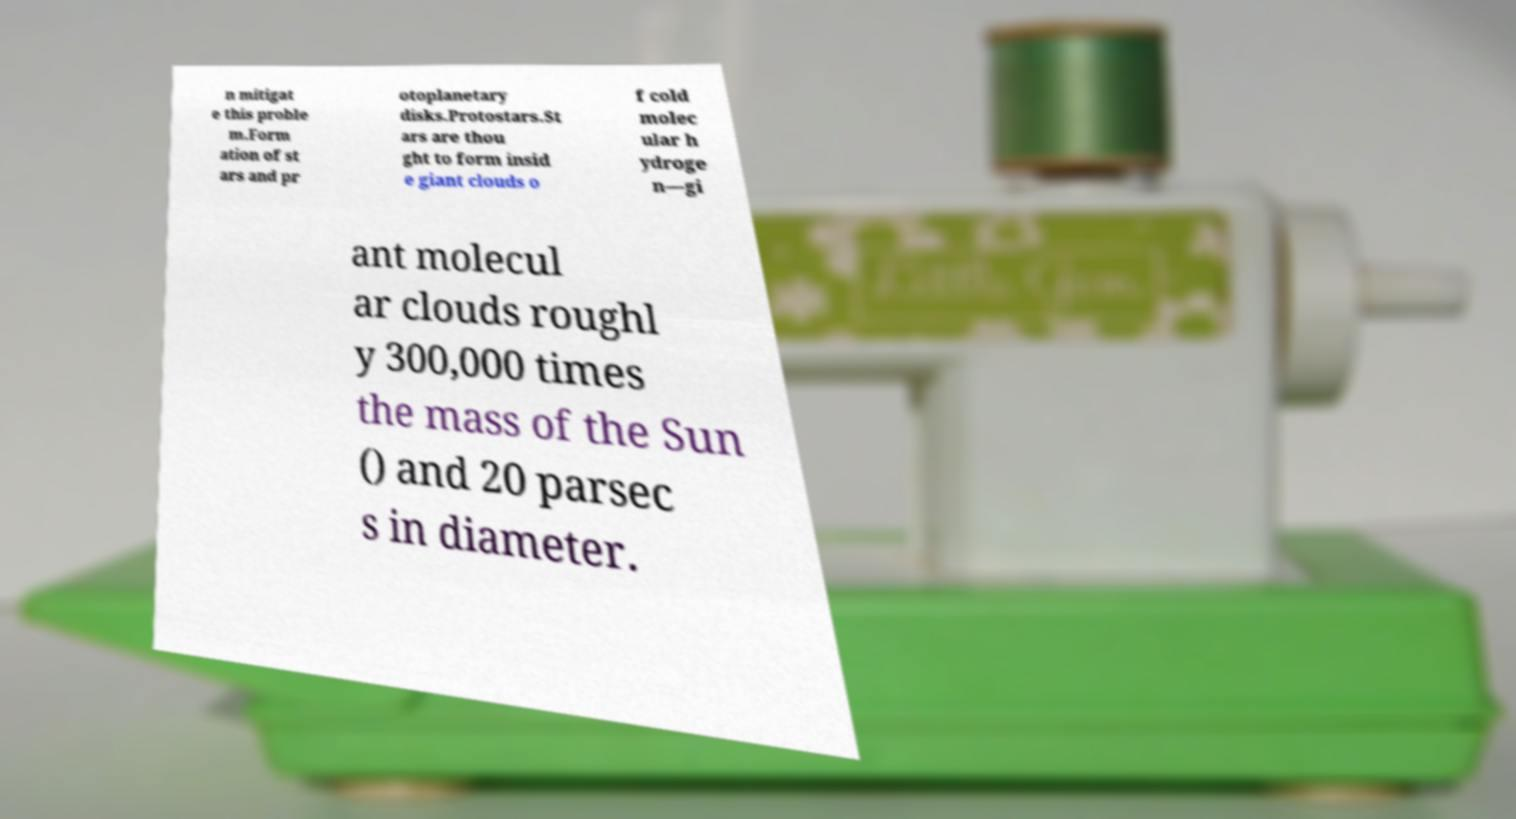Can you accurately transcribe the text from the provided image for me? n mitigat e this proble m.Form ation of st ars and pr otoplanetary disks.Protostars.St ars are thou ght to form insid e giant clouds o f cold molec ular h ydroge n—gi ant molecul ar clouds roughl y 300,000 times the mass of the Sun () and 20 parsec s in diameter. 